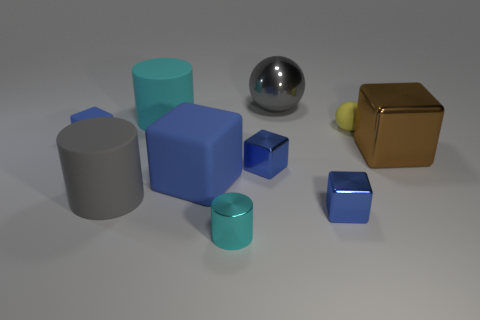Subtract all cyan balls. How many blue blocks are left? 4 Subtract all brown blocks. How many blocks are left? 4 Subtract all small blue rubber blocks. How many blocks are left? 4 Subtract all green blocks. Subtract all yellow spheres. How many blocks are left? 5 Subtract all cylinders. How many objects are left? 7 Add 7 yellow spheres. How many yellow spheres are left? 8 Add 7 small gray metal blocks. How many small gray metal blocks exist? 7 Subtract 0 red spheres. How many objects are left? 10 Subtract all metal things. Subtract all yellow balls. How many objects are left? 4 